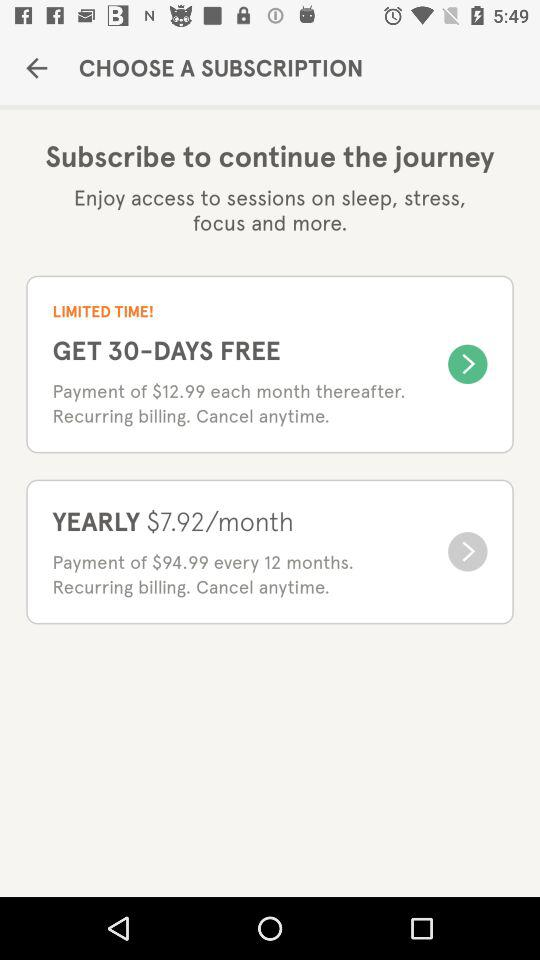How many months does the $94.99 payment cover? The $94.99 payment covers 12 months. 